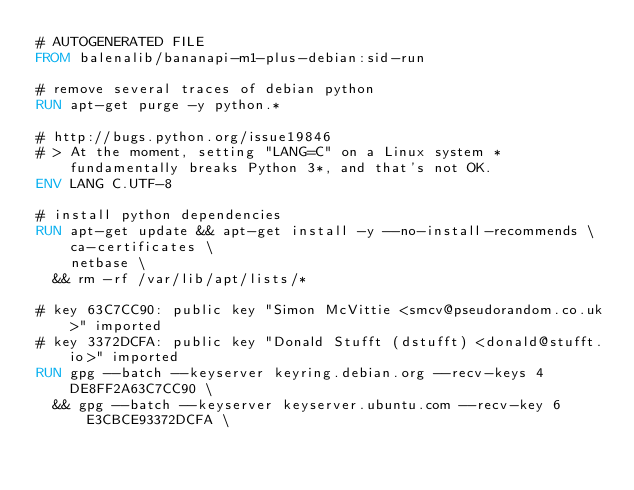<code> <loc_0><loc_0><loc_500><loc_500><_Dockerfile_># AUTOGENERATED FILE
FROM balenalib/bananapi-m1-plus-debian:sid-run

# remove several traces of debian python
RUN apt-get purge -y python.*

# http://bugs.python.org/issue19846
# > At the moment, setting "LANG=C" on a Linux system *fundamentally breaks Python 3*, and that's not OK.
ENV LANG C.UTF-8

# install python dependencies
RUN apt-get update && apt-get install -y --no-install-recommends \
		ca-certificates \
		netbase \
	&& rm -rf /var/lib/apt/lists/*

# key 63C7CC90: public key "Simon McVittie <smcv@pseudorandom.co.uk>" imported
# key 3372DCFA: public key "Donald Stufft (dstufft) <donald@stufft.io>" imported
RUN gpg --batch --keyserver keyring.debian.org --recv-keys 4DE8FF2A63C7CC90 \
	&& gpg --batch --keyserver keyserver.ubuntu.com --recv-key 6E3CBCE93372DCFA \</code> 